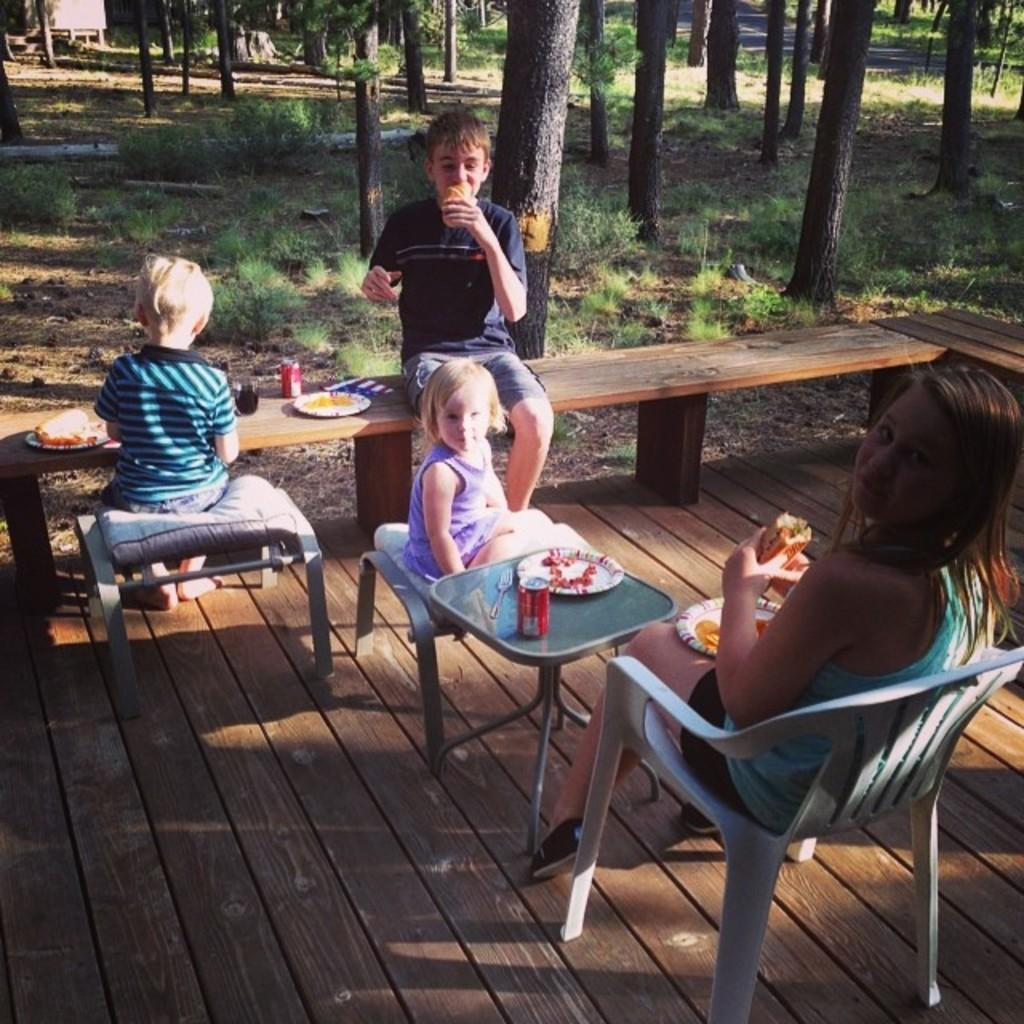How many people are present in the image? There are four people in the image. What objects can be seen on the table? There is a plate, a fork, and a coke tin on the table. What is visible in the background of the image? There are trees visible in the background of the image. What type of payment is being made in the image? There is no indication of any payment being made in the image. Can you see any space-related objects or elements in the image? No, there are no space-related objects or elements present in the image. 